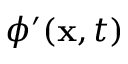Convert formula to latex. <formula><loc_0><loc_0><loc_500><loc_500>\phi ^ { \prime } ( x , t )</formula> 